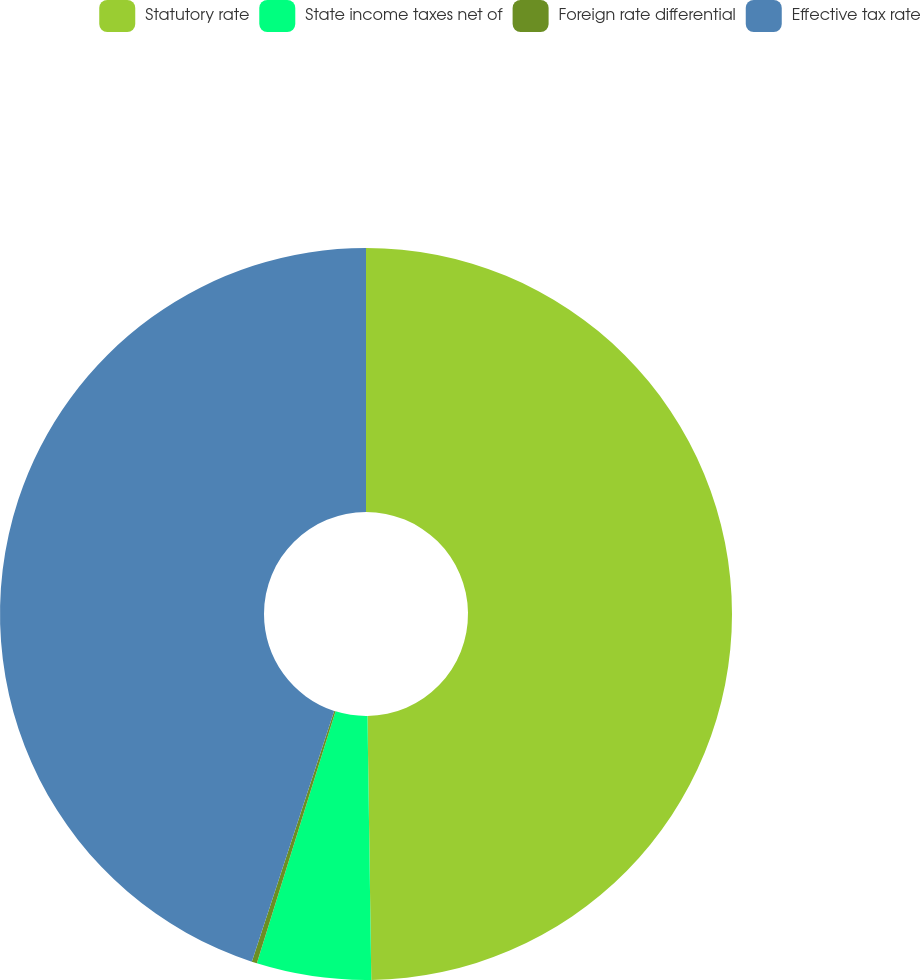<chart> <loc_0><loc_0><loc_500><loc_500><pie_chart><fcel>Statutory rate<fcel>State income taxes net of<fcel>Foreign rate differential<fcel>Effective tax rate<nl><fcel>49.77%<fcel>5.05%<fcel>0.23%<fcel>44.95%<nl></chart> 